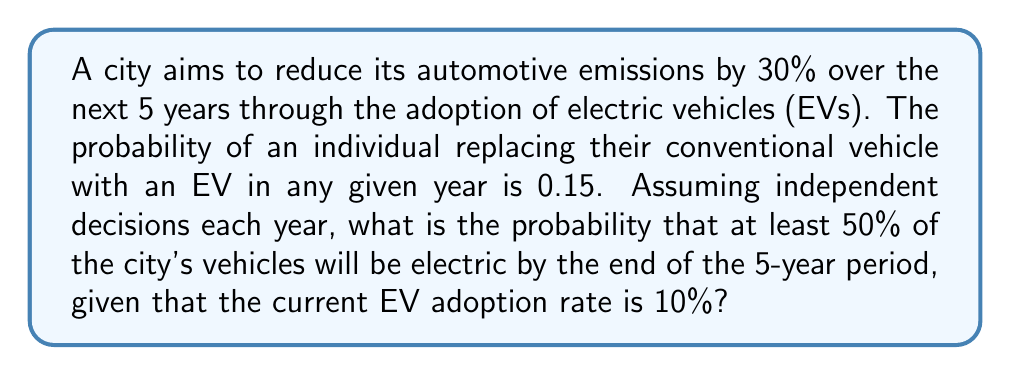Help me with this question. Let's approach this step-by-step:

1) First, we need to calculate the probability of a single vehicle being replaced by an EV over 5 years.
   Let $p$ be the probability of not replacing in a single year:
   $p = 1 - 0.15 = 0.85$

   The probability of not replacing over 5 years is:
   $p^5 = 0.85^5 = 0.4437$

   Therefore, the probability of replacing within 5 years is:
   $1 - 0.4437 = 0.5563$

2) Now, we need to find the proportion of additional EVs needed to reach 50% adoption:
   Current adoption: 10%
   Target adoption: 50%
   Additional adoption needed: 40%

3) Let $X$ be the number of additional vehicles that become EVs out of the remaining 90% conventional vehicles.
   $X$ follows a binomial distribution with parameters:
   $n = 90$ (as we're dealing with percentages)
   $p = 0.5563$ (probability calculated in step 1)

4) We need to find $P(X \geq 36)$, as 36 additional percentage points would bring the total to 50%.

5) Using the binomial cumulative distribution function:

   $$P(X \geq 36) = 1 - P(X \leq 35) = 1 - \sum_{k=0}^{35} \binom{90}{k} (0.5563)^k (1-0.5563)^{90-k}$$

6) This can be calculated using statistical software or a calculator with binomial CDF function.
   The result is approximately 0.9978.

Therefore, the probability of achieving at least 50% EV adoption within 5 years is about 0.9978 or 99.78%.
Answer: 0.9978 